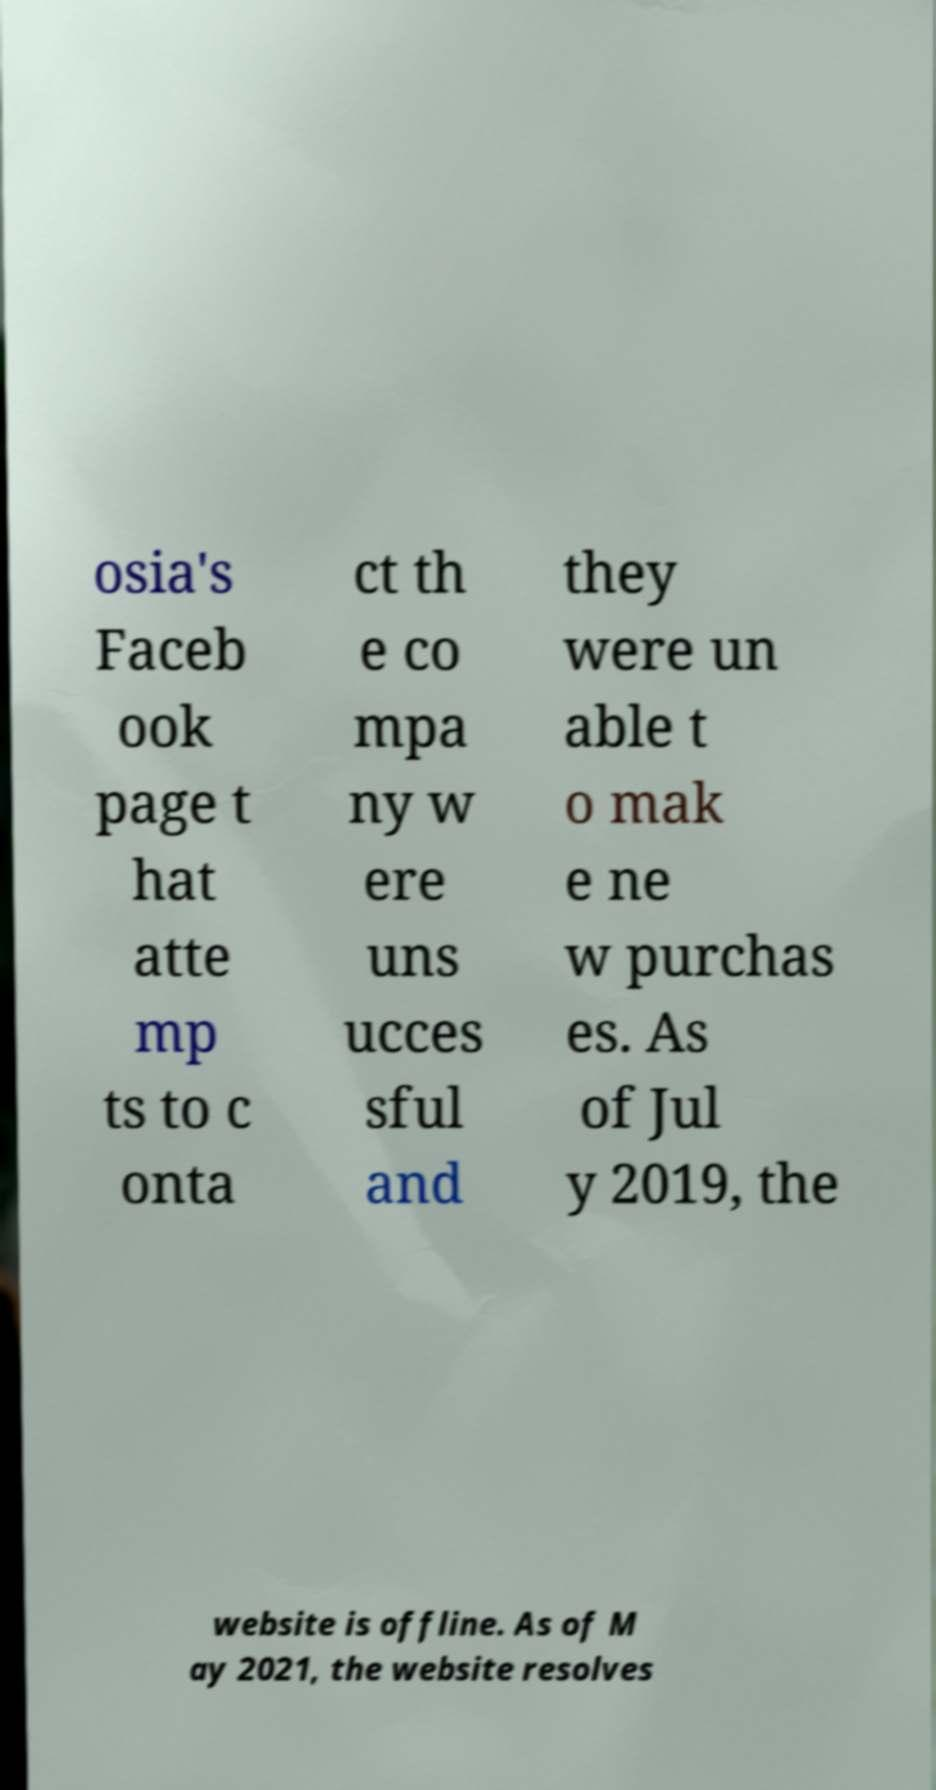Please identify and transcribe the text found in this image. osia's Faceb ook page t hat atte mp ts to c onta ct th e co mpa ny w ere uns ucces sful and they were un able t o mak e ne w purchas es. As of Jul y 2019, the website is offline. As of M ay 2021, the website resolves 